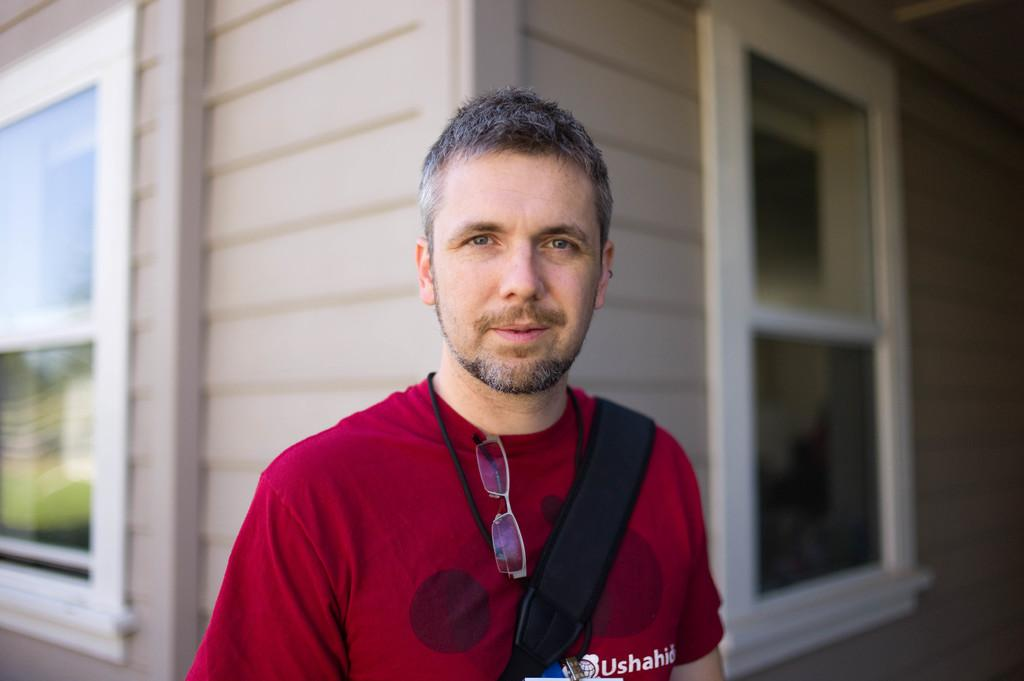Who is the main subject in the image? There is a man in the image. What is the man standing in front of? The man is standing in front of a place with windows. Who is the man looking at? The man is looking at someone. What is the man writing in the image? There is no indication in the image that the man is writing anything. 